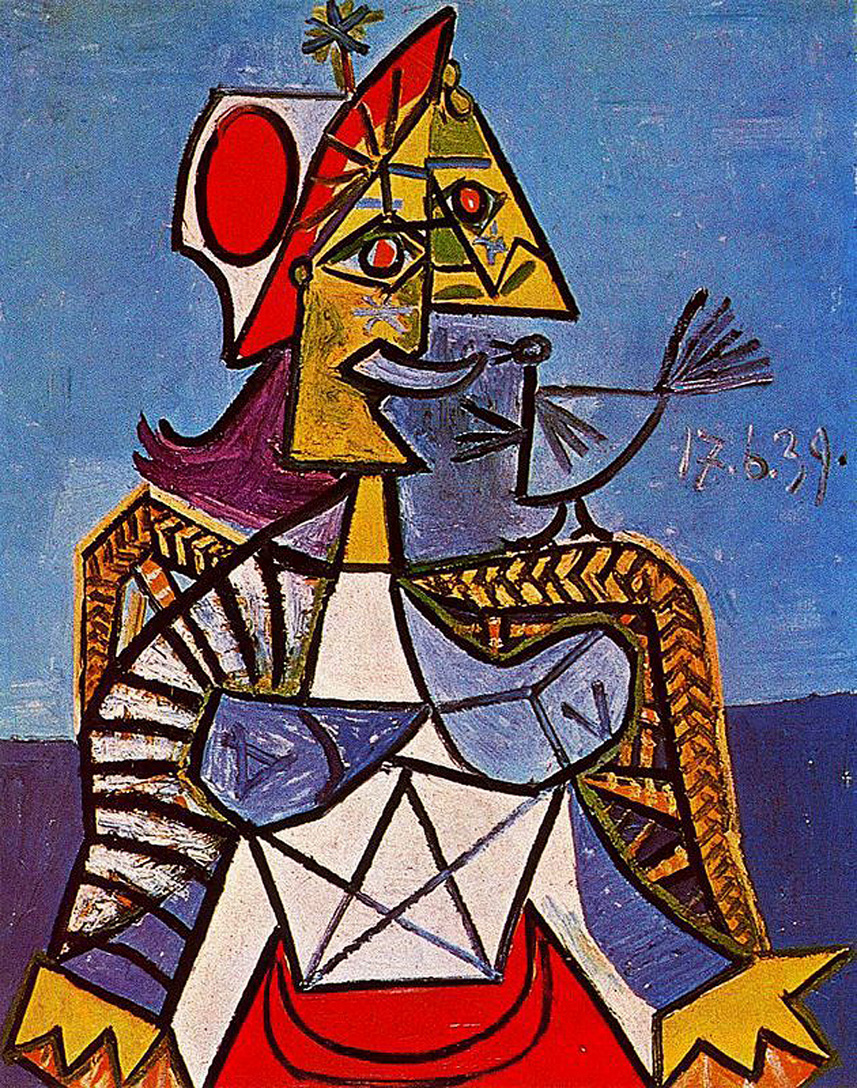If this artwork were to come to life, what sounds and movements would you expect to see and hear? If this Cubist artwork were to come to life, it would be a symphony of vibrant and abstract elements. The angular shapes and sharp lines might create rhythmic, mechanical sounds as they shift and rotate, much like the cogs in a machine. The bright colors would pulsate with energy, perhaps emitting a harmonious hum or a series of musical notes. The crowned figure could move with a regal grace, each motion fluid yet segmented, as if the geometry dictated a precise dance. The bird in their hand would flutter delicately, its song a melodious and soothing contrast to the structured environment around it. Overall, this lively scene would be a blend of harmonious rhythms, dynamic movements, and contrasting sounds, reflecting the unique and multifaceted nature of the artwork. 